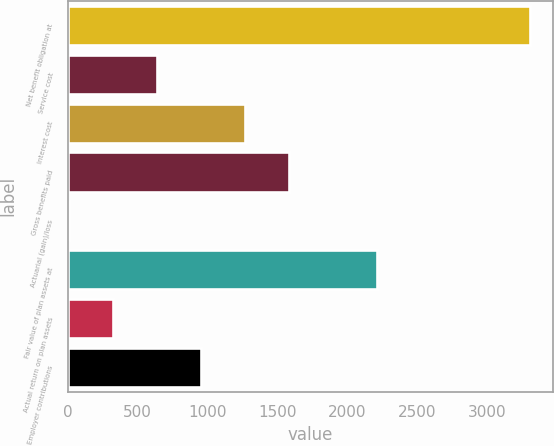Convert chart. <chart><loc_0><loc_0><loc_500><loc_500><bar_chart><fcel>Net benefit obligation at<fcel>Service cost<fcel>Interest cost<fcel>Gross benefits paid<fcel>Actuarial (gain)/loss<fcel>Fair value of plan assets at<fcel>Actual return on plan assets<fcel>Employer contributions<nl><fcel>3306.5<fcel>637<fcel>1266<fcel>1580.5<fcel>8<fcel>2209.5<fcel>322.5<fcel>951.5<nl></chart> 